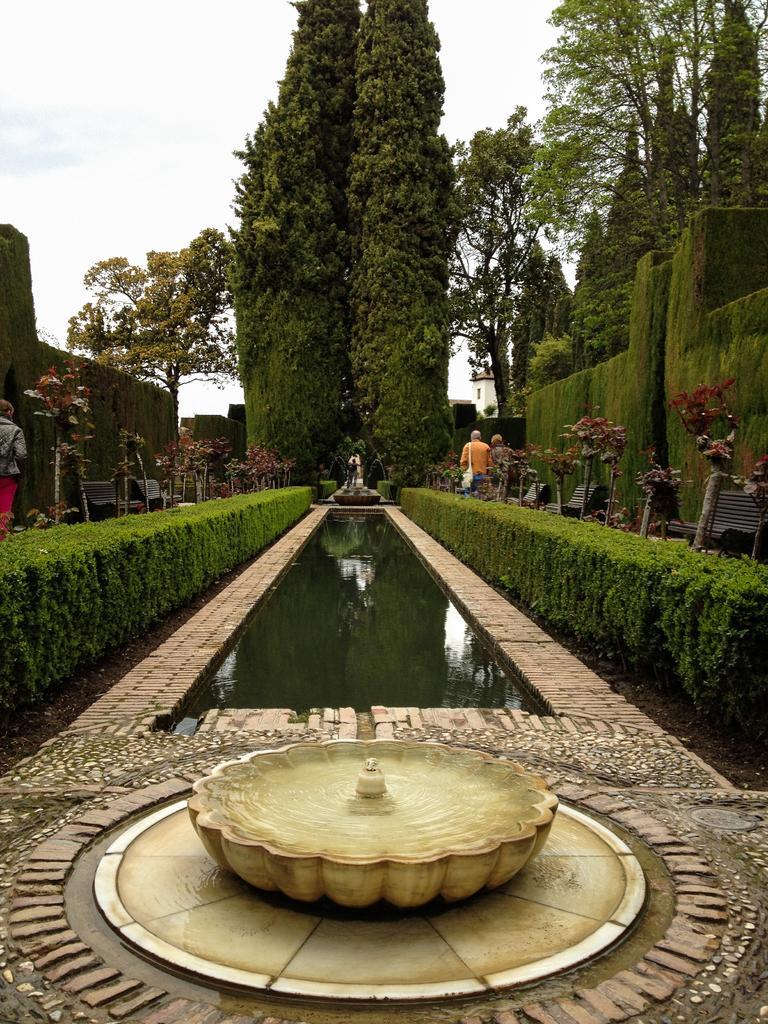In one or two sentences, can you explain what this image depicts? In this image there is the water canal in the center. At the bottom there is a water fountain. On the either sides of the water there are hedges. Behind the hedges there are benches, plants and trees. There are a few people in the image. At the top there is the sky. 